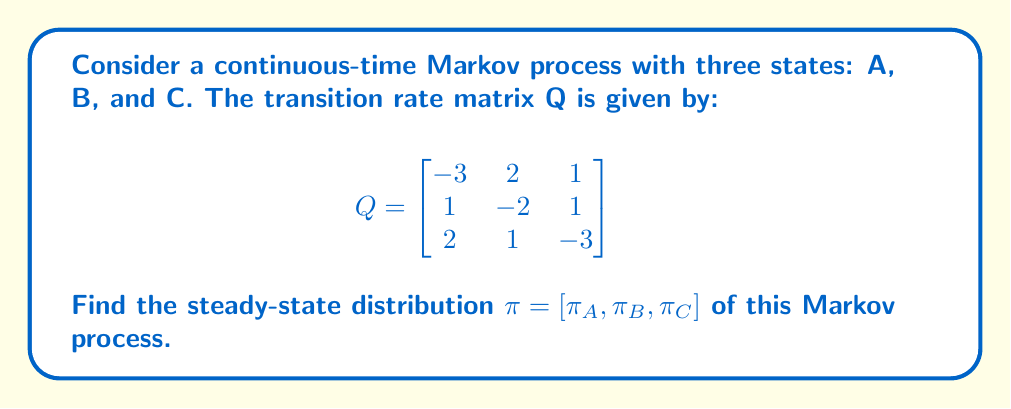Teach me how to tackle this problem. To find the steady-state distribution, we need to solve the equation $\pi Q = 0$ along with the condition that the probabilities sum to 1.

Step 1: Set up the system of equations
$$\pi Q = 0$$
$$[\pi_A, \pi_B, \pi_C] \begin{bmatrix}
-3 & 2 & 1 \\
1 & -2 & 1 \\
2 & 1 & -3
\end{bmatrix} = [0, 0, 0]$$

This gives us:
$$-3\pi_A + \pi_B + 2\pi_C = 0$$
$$2\pi_A - 2\pi_B + \pi_C = 0$$
$$\pi_A + \pi_B - 3\pi_C = 0$$

Step 2: Add the normalization condition
$$\pi_A + \pi_B + \pi_C = 1$$

Step 3: Solve the system of equations
We can use the first three equations and the normalization condition to solve for $\pi_A, \pi_B, \pi_C$.

From the first equation:
$$\pi_B = 3\pi_A - 2\pi_C$$

Substituting this into the second equation:
$$2\pi_A - 2(3\pi_A - 2\pi_C) + \pi_C = 0$$
$$2\pi_A - 6\pi_A + 4\pi_C + \pi_C = 0$$
$$-4\pi_A + 5\pi_C = 0$$
$$\pi_C = \frac{4}{5}\pi_A$$

Now, using the normalization condition:
$$\pi_A + (3\pi_A - 2\pi_C) + \pi_C = 1$$
$$\pi_A + 3\pi_A - 2(\frac{4}{5}\pi_A) + \frac{4}{5}\pi_A = 1$$
$$4\pi_A - \frac{8}{5}\pi_A + \frac{4}{5}\pi_A = 1$$
$$\frac{16}{5}\pi_A = 1$$
$$\pi_A = \frac{5}{16}$$

We can now find $\pi_B$ and $\pi_C$:
$$\pi_C = \frac{4}{5}\pi_A = \frac{4}{5} \cdot \frac{5}{16} = \frac{1}{4}$$
$$\pi_B = 1 - \pi_A - \pi_C = 1 - \frac{5}{16} - \frac{1}{4} = \frac{7}{16}$$

Step 4: Verify the solution
We can check that $\pi Q = 0$:
$$[\frac{5}{16}, \frac{7}{16}, \frac{1}{4}] \begin{bmatrix}
-3 & 2 & 1 \\
1 & -2 & 1 \\
2 & 1 & -3
\end{bmatrix} = [0, 0, 0]$$
Answer: $\pi = [\frac{5}{16}, \frac{7}{16}, \frac{1}{4}]$ 